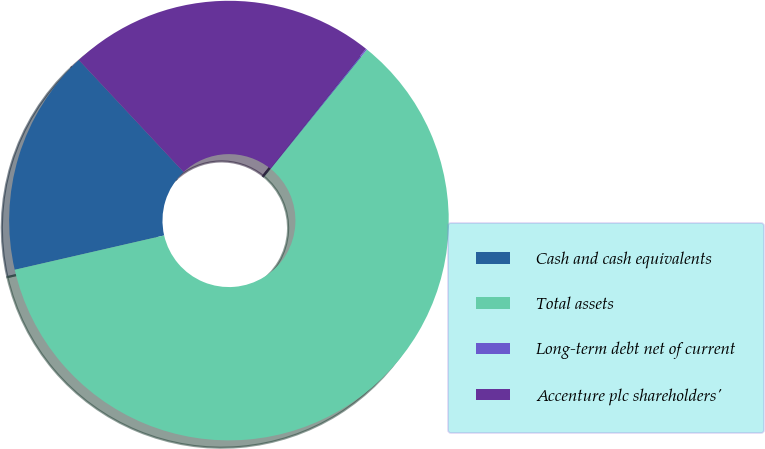<chart> <loc_0><loc_0><loc_500><loc_500><pie_chart><fcel>Cash and cash equivalents<fcel>Total assets<fcel>Long-term debt net of current<fcel>Accenture plc shareholders'<nl><fcel>16.63%<fcel>60.6%<fcel>0.09%<fcel>22.68%<nl></chart> 